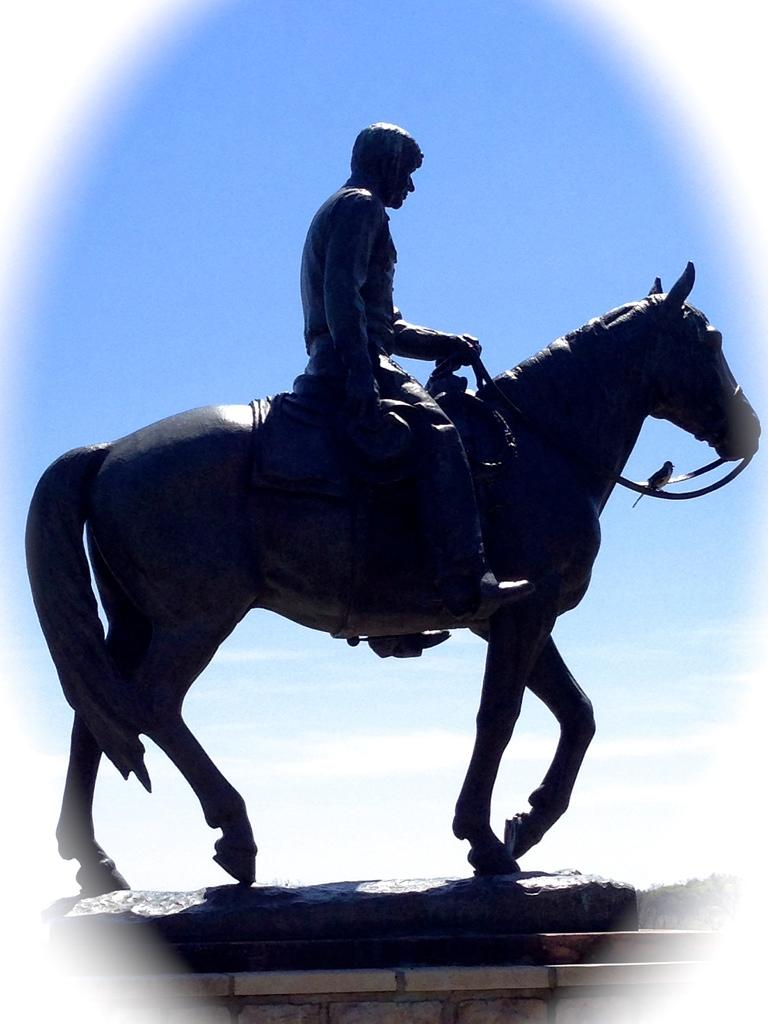What is the main subject of the image? There is a statue of a horse in the image. What is the man in the image doing? A man is sitting on the horse statue. What can be seen in the background of the image? There is a sky visible in the background of the image. How many clover leaves can be seen on the horse statue in the image? There are no clover leaves present on the horse statue in the image. What emotion is the man expressing while sitting on the horse statue in the image? The image does not provide information about the man's emotions, so it cannot be determined from the image. 